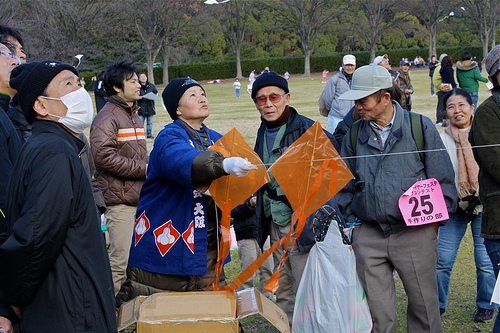Please extract the text content from this image. 25 